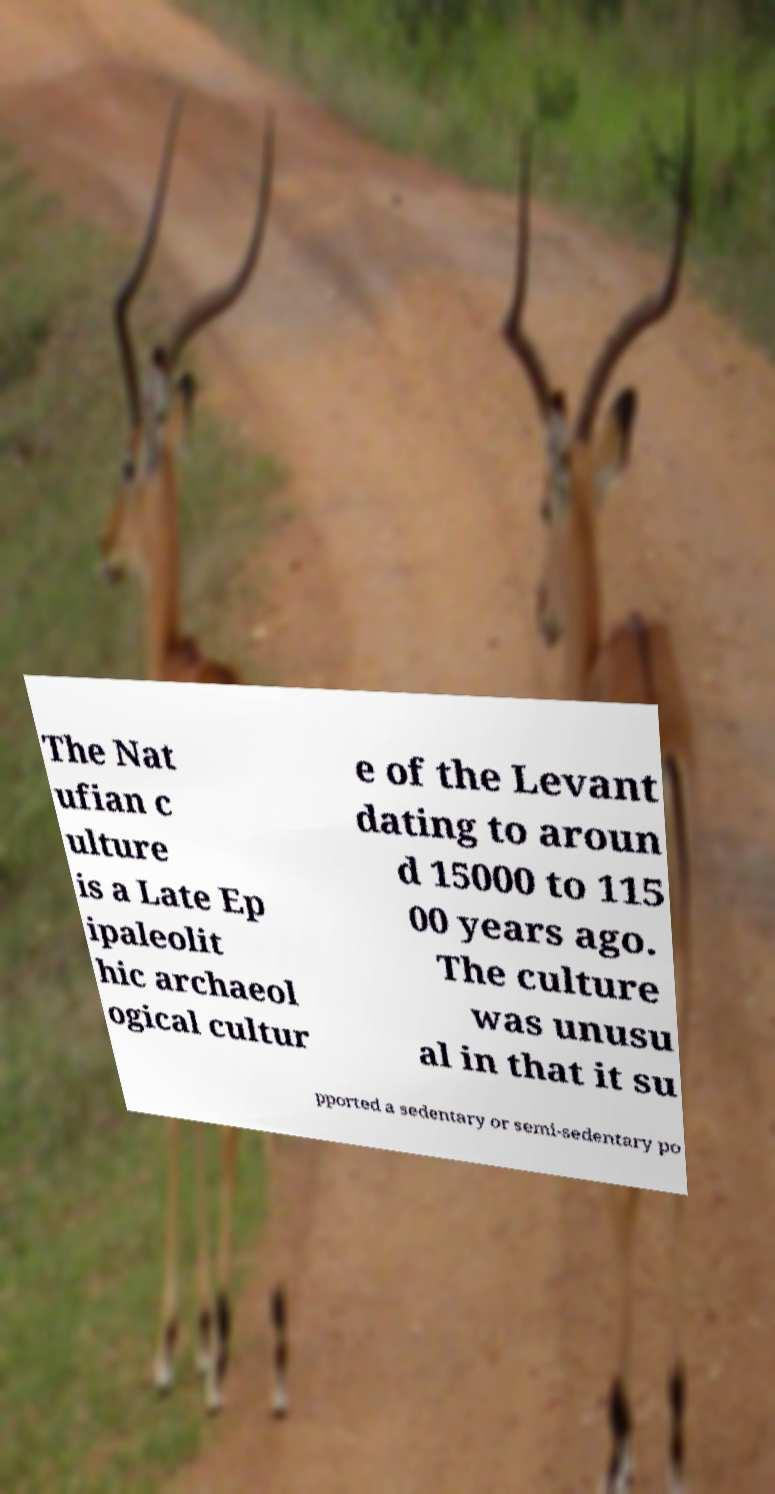Please read and relay the text visible in this image. What does it say? The Nat ufian c ulture is a Late Ep ipaleolit hic archaeol ogical cultur e of the Levant dating to aroun d 15000 to 115 00 years ago. The culture was unusu al in that it su pported a sedentary or semi-sedentary po 